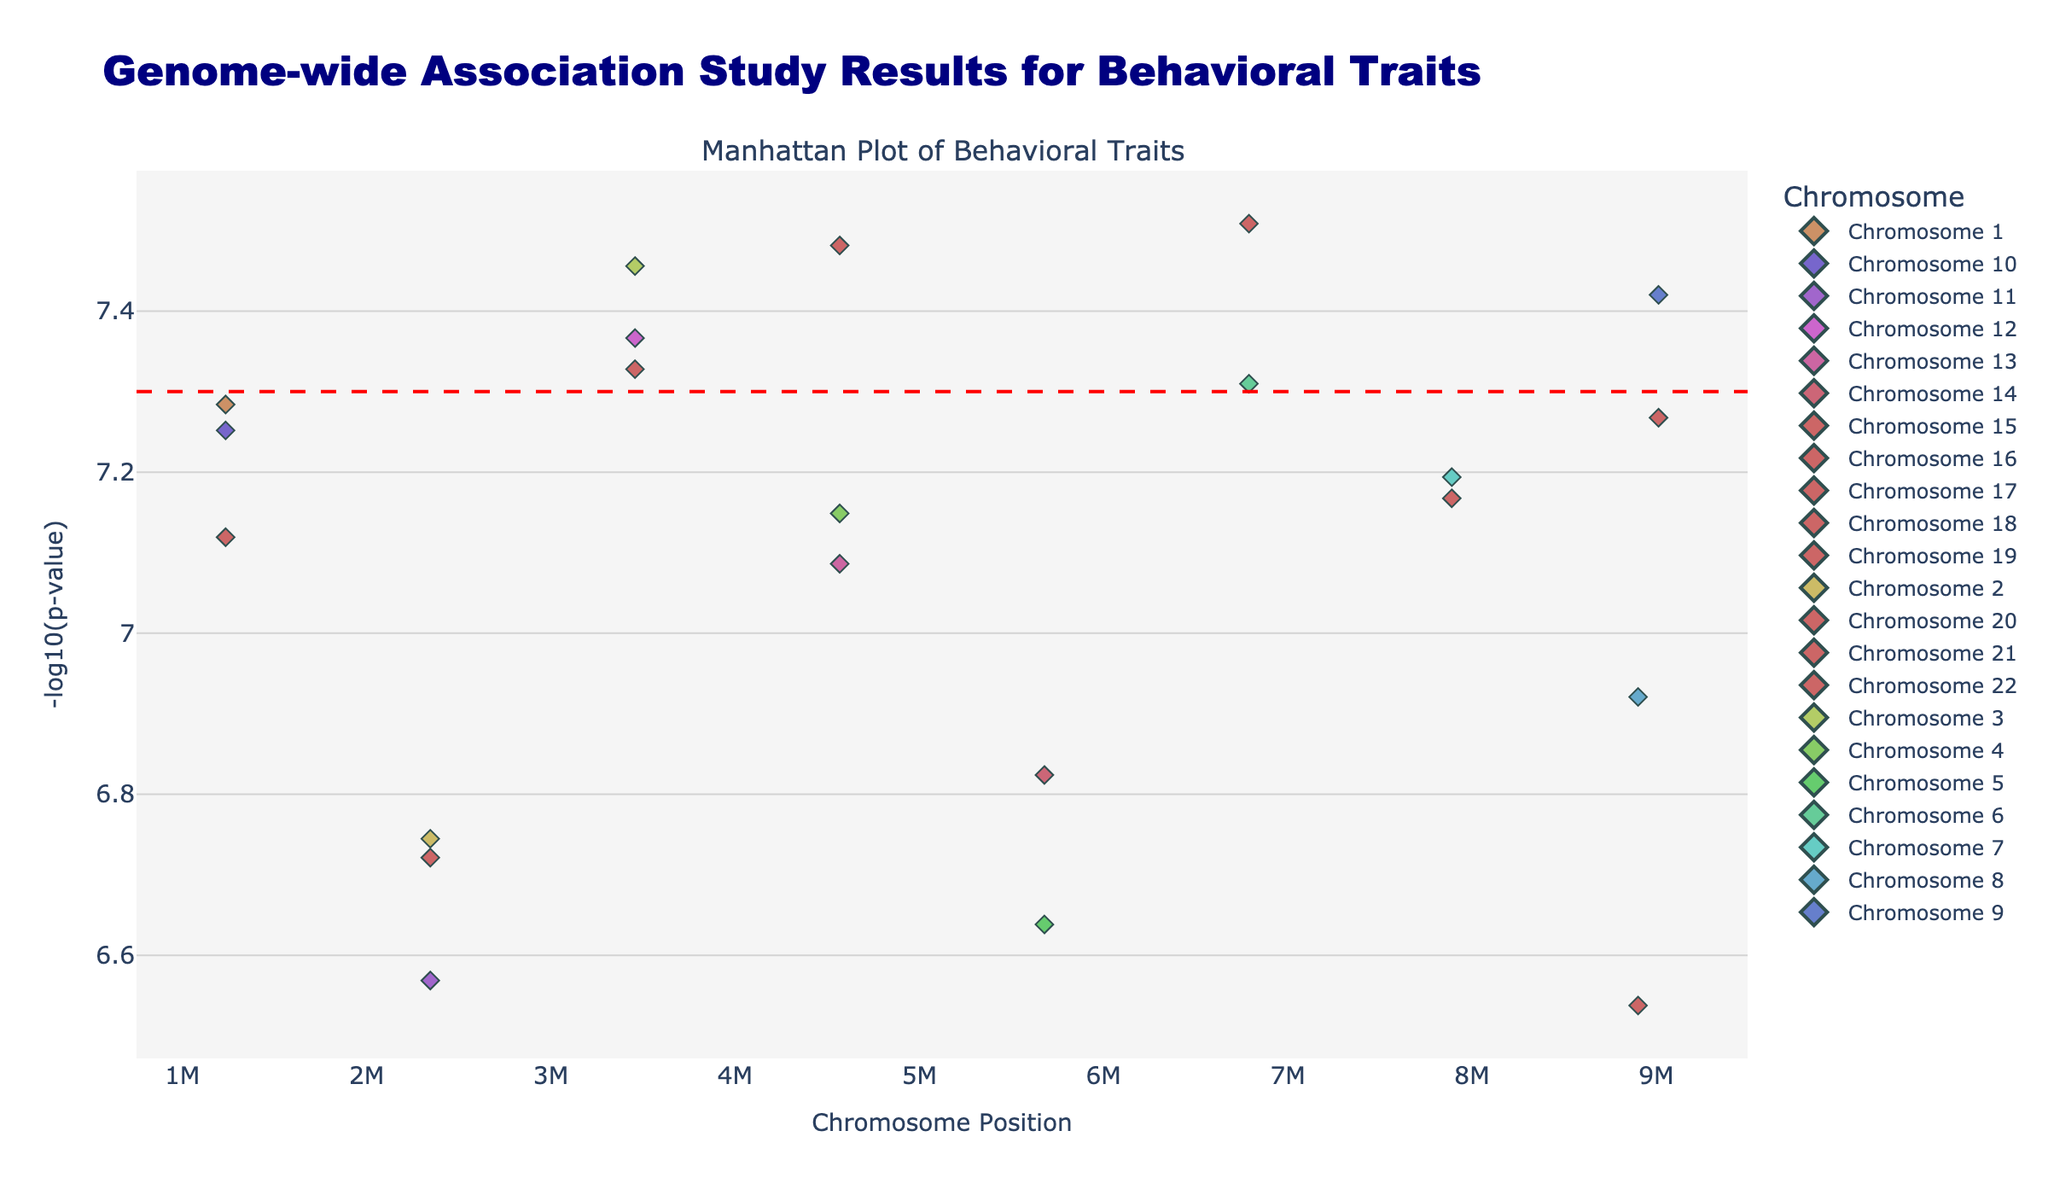Which chromosome shows the highest -log10(p-value) for any trait? To find out which chromosome shows the highest -log10(p-value), look for the highest point in the plot and observe the corresponding chromosome label. The highest point is likely to be on the y-axis that has the maximum value. In this plot, Chromosome 1 with the trait "Reading Speed" has the highest -log10(p-value).
Answer: Chromosome 1 What trait corresponds to the highest -log10(p-value) on the plot? To identify the trait with the highest -log10(p-value), find the data point that reaches the highest vertical position and check the hover text or legend for the trait name. The highest point represents the trait "Reading Speed".
Answer: Reading Speed What is the significance threshold level plotted? The significance threshold in a Manhattan Plot is typically marked by a horizontal line. By visually inspecting the line and referring to the y-axis, the threshold's value can be determined. The plot indicates a significance threshold at -log10(p-value) = 7.3.
Answer: 7.3 How many traits have a -log10(p-value) above the significance threshold? Count the number of data points lying above the horizontal red dashed line at -log10(p-value) = 7.3. By visually inspecting the plot, only one trait (Reading Speed on Chromosome 1) is above the threshold.
Answer: 1 Which chromosome has the most data points? To determine the chromosome with the most data points, count the number of markers for each chromosome. From a visual inspection of the plot, all chromosomes have an equal number of data points (one each).
Answer: All chromosomes have 1 data point Which trait has the lowest -log10(p-value) among those listed? To find the trait with the lowest -log10(p-value), look for the lowest vertical data point on the plot and read the corresponding hover text. The lowest point corresponds to "Artistic Ability" on Chromosome 20.
Answer: Artistic Ability Describe how you can determine which chromosome a data point belongs to in the plot. Each data point in the Manhattan Plot is color-coded according to the chromosome. By referencing the legend on the right side of the plot, the color of the point can be matched with the corresponding chromosome. Additionally, hovering over a data point reveals detailed information including the chromosome.
Answer: Color and hover text What is the y-axis representing in this plot? The y-axis in a Manhattan Plot typically represents the -log10(p-value) of the data points, which indicates the statistical significance of the SNPs. In this case, it shows how significant each SNP is concerning the behavioral traits.
Answer: -log10(p-value) How many traits have a -log10(p-value) above 6 but below the significance threshold? Count the number of data points that are between values 6 and 7.3 on the y-axis. From visual inspection, these traits include "Math Aptitude" and "Attention Span".
Answer: 2 Which chromosome has the highest diversity of traits? To determine the diversity of traits, observe the unique data points (each representing a different trait) associated with each chromosome. Since each chromosome has a different trait, all chromosomes equally exhibit a diversity of one unique trait.
Answer: Equal diversity 